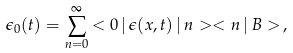<formula> <loc_0><loc_0><loc_500><loc_500>\epsilon _ { 0 } ( t ) = \sum _ { n = 0 } ^ { \infty } { < 0 \, | \, \epsilon ( x , t ) \, | \, n > < n \, | \, B > } \, ,</formula> 